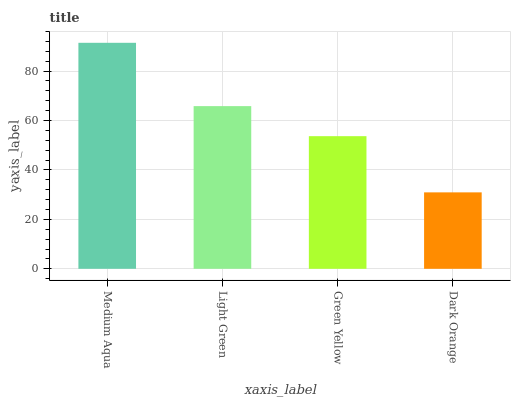Is Dark Orange the minimum?
Answer yes or no. Yes. Is Medium Aqua the maximum?
Answer yes or no. Yes. Is Light Green the minimum?
Answer yes or no. No. Is Light Green the maximum?
Answer yes or no. No. Is Medium Aqua greater than Light Green?
Answer yes or no. Yes. Is Light Green less than Medium Aqua?
Answer yes or no. Yes. Is Light Green greater than Medium Aqua?
Answer yes or no. No. Is Medium Aqua less than Light Green?
Answer yes or no. No. Is Light Green the high median?
Answer yes or no. Yes. Is Green Yellow the low median?
Answer yes or no. Yes. Is Medium Aqua the high median?
Answer yes or no. No. Is Medium Aqua the low median?
Answer yes or no. No. 